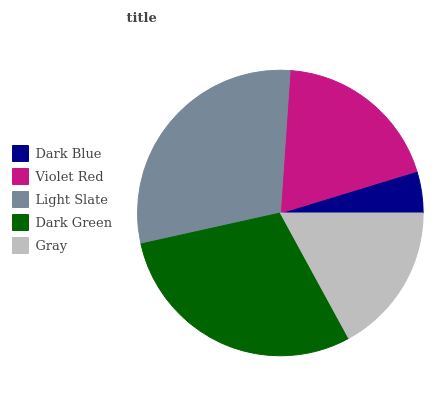Is Dark Blue the minimum?
Answer yes or no. Yes. Is Light Slate the maximum?
Answer yes or no. Yes. Is Violet Red the minimum?
Answer yes or no. No. Is Violet Red the maximum?
Answer yes or no. No. Is Violet Red greater than Dark Blue?
Answer yes or no. Yes. Is Dark Blue less than Violet Red?
Answer yes or no. Yes. Is Dark Blue greater than Violet Red?
Answer yes or no. No. Is Violet Red less than Dark Blue?
Answer yes or no. No. Is Violet Red the high median?
Answer yes or no. Yes. Is Violet Red the low median?
Answer yes or no. Yes. Is Dark Green the high median?
Answer yes or no. No. Is Dark Green the low median?
Answer yes or no. No. 